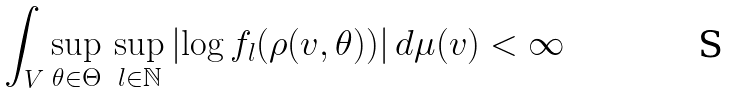<formula> <loc_0><loc_0><loc_500><loc_500>\int _ { V } \sup _ { \theta \in \Theta } \, \sup _ { l \in \mathbb { N } } \left | \log f _ { l } ( \rho ( v , \theta ) ) \right | d \mu ( v ) < \infty</formula> 